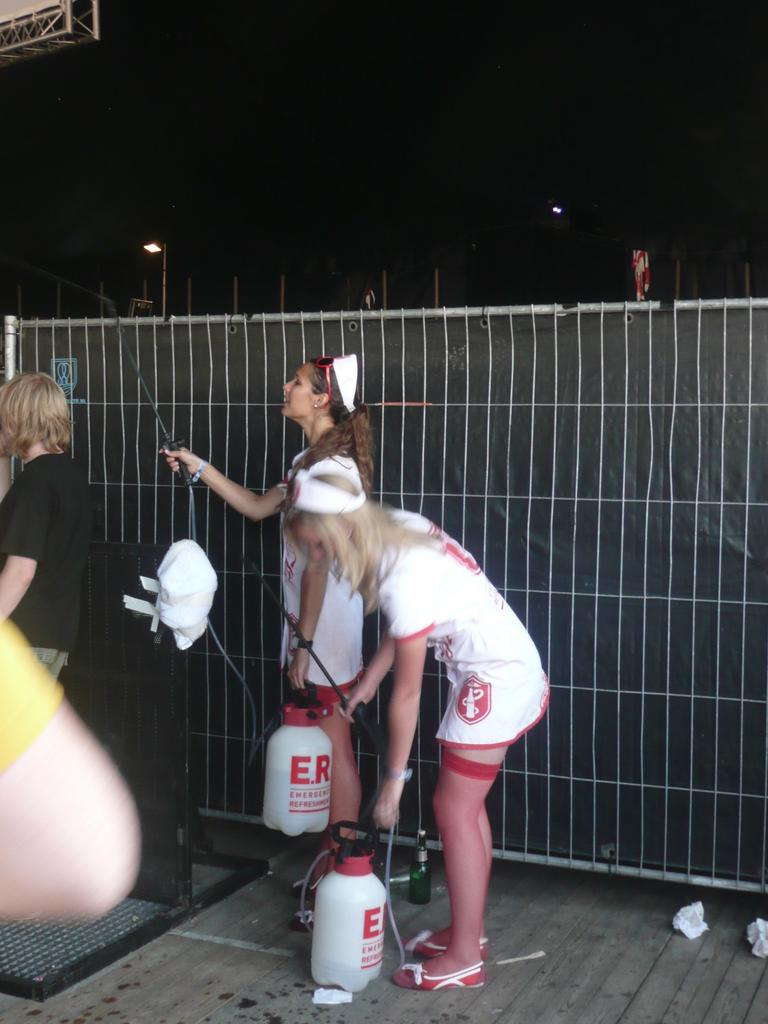Provide a one-sentence caption for the provided image. Two women dressed up like nurses carry bottles marked E.R. 